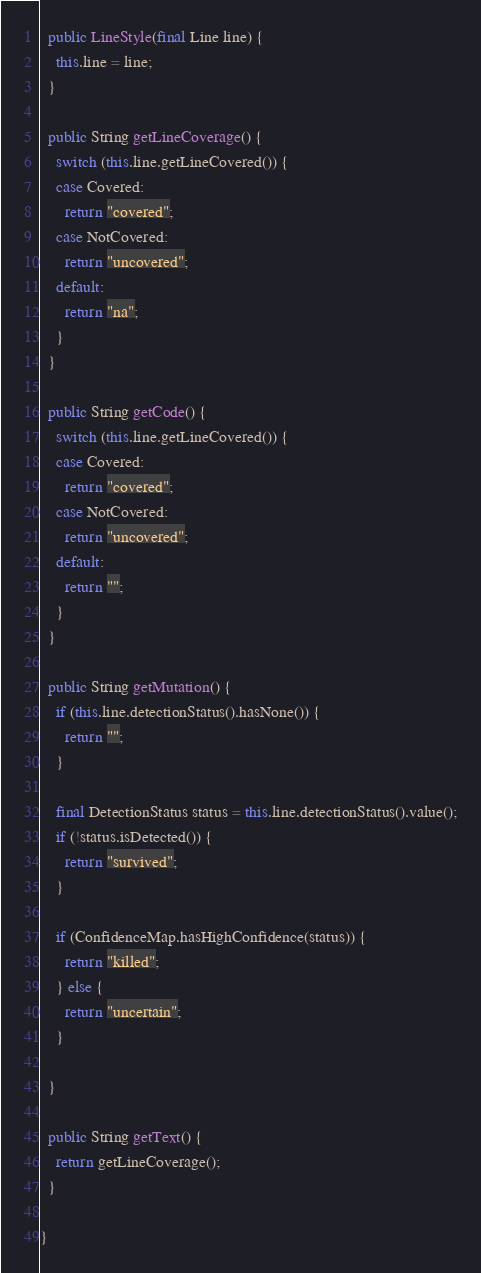Convert code to text. <code><loc_0><loc_0><loc_500><loc_500><_Java_>
  public LineStyle(final Line line) {
    this.line = line;
  }

  public String getLineCoverage() {
    switch (this.line.getLineCovered()) {
    case Covered:
      return "covered";
    case NotCovered:
      return "uncovered";
    default:
      return "na";
    }
  }

  public String getCode() {
    switch (this.line.getLineCovered()) {
    case Covered:
      return "covered";
    case NotCovered:
      return "uncovered";
    default:
      return "";
    }
  }

  public String getMutation() {
    if (this.line.detectionStatus().hasNone()) {
      return "";
    }

    final DetectionStatus status = this.line.detectionStatus().value();
    if (!status.isDetected()) {
      return "survived";
    }

    if (ConfidenceMap.hasHighConfidence(status)) {
      return "killed";
    } else {
      return "uncertain";
    }

  }

  public String getText() {
    return getLineCoverage();
  }

}
</code> 